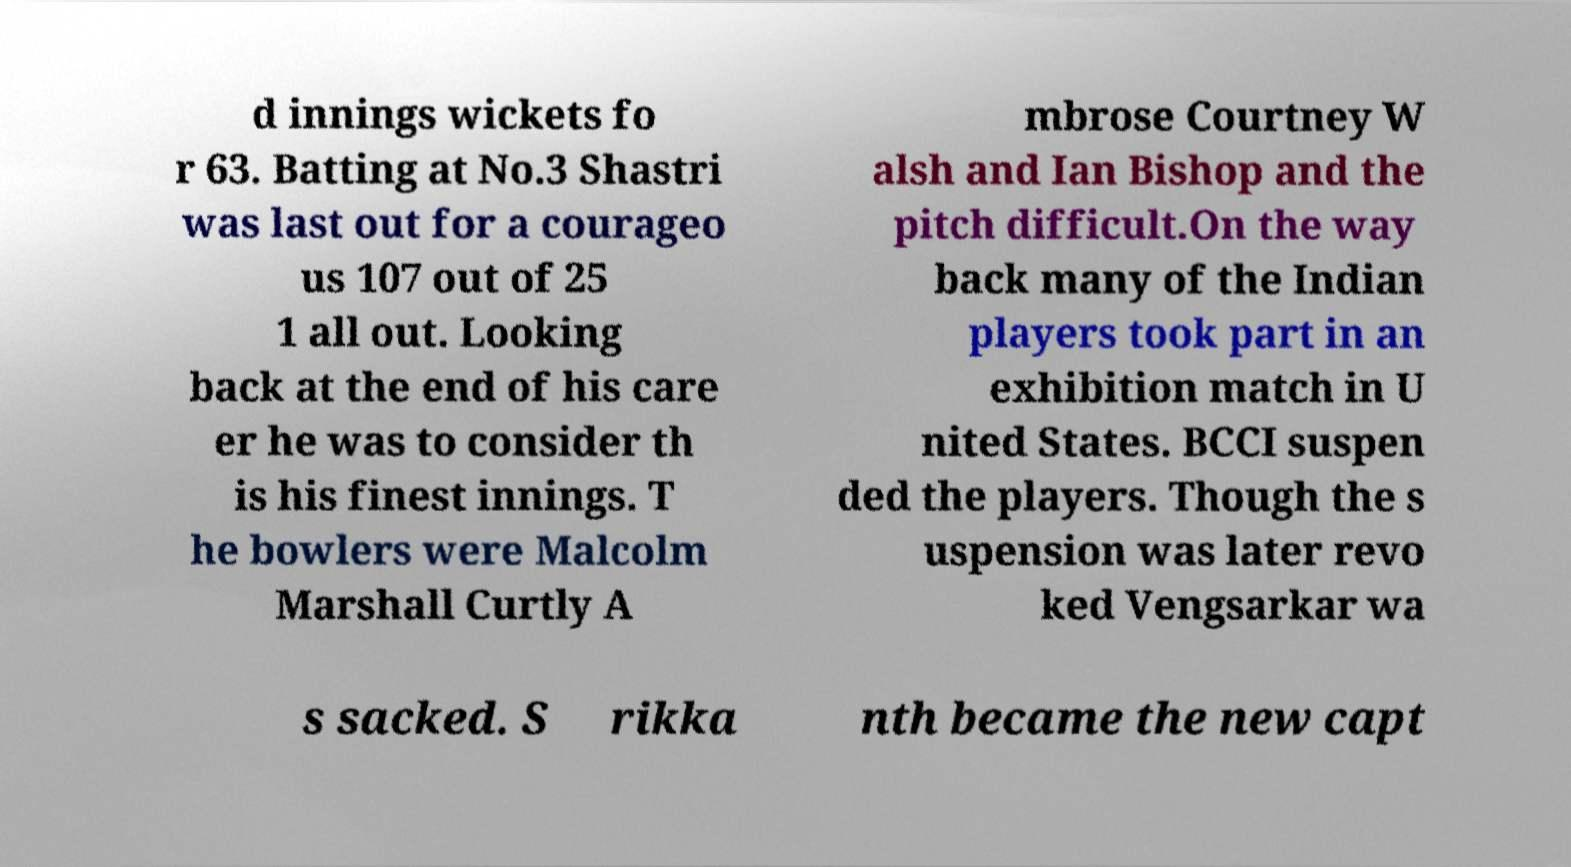What messages or text are displayed in this image? I need them in a readable, typed format. d innings wickets fo r 63. Batting at No.3 Shastri was last out for a courageo us 107 out of 25 1 all out. Looking back at the end of his care er he was to consider th is his finest innings. T he bowlers were Malcolm Marshall Curtly A mbrose Courtney W alsh and Ian Bishop and the pitch difficult.On the way back many of the Indian players took part in an exhibition match in U nited States. BCCI suspen ded the players. Though the s uspension was later revo ked Vengsarkar wa s sacked. S rikka nth became the new capt 